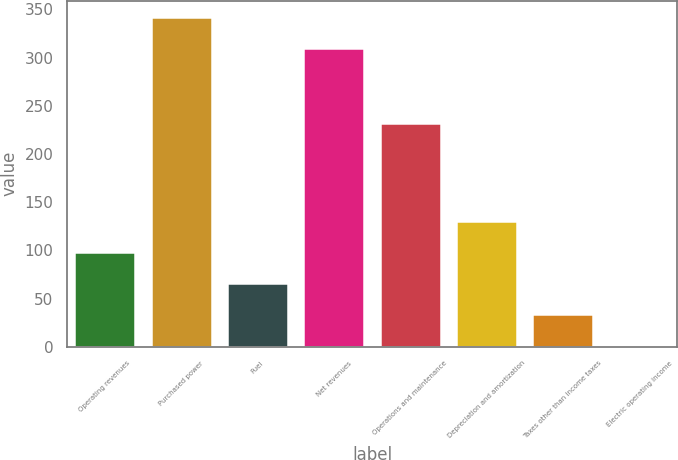Convert chart to OTSL. <chart><loc_0><loc_0><loc_500><loc_500><bar_chart><fcel>Operating revenues<fcel>Purchased power<fcel>Fuel<fcel>Net revenues<fcel>Operations and maintenance<fcel>Depreciation and amortization<fcel>Taxes other than income taxes<fcel>Electric operating income<nl><fcel>98<fcel>342<fcel>66<fcel>310<fcel>232<fcel>130<fcel>34<fcel>2<nl></chart> 